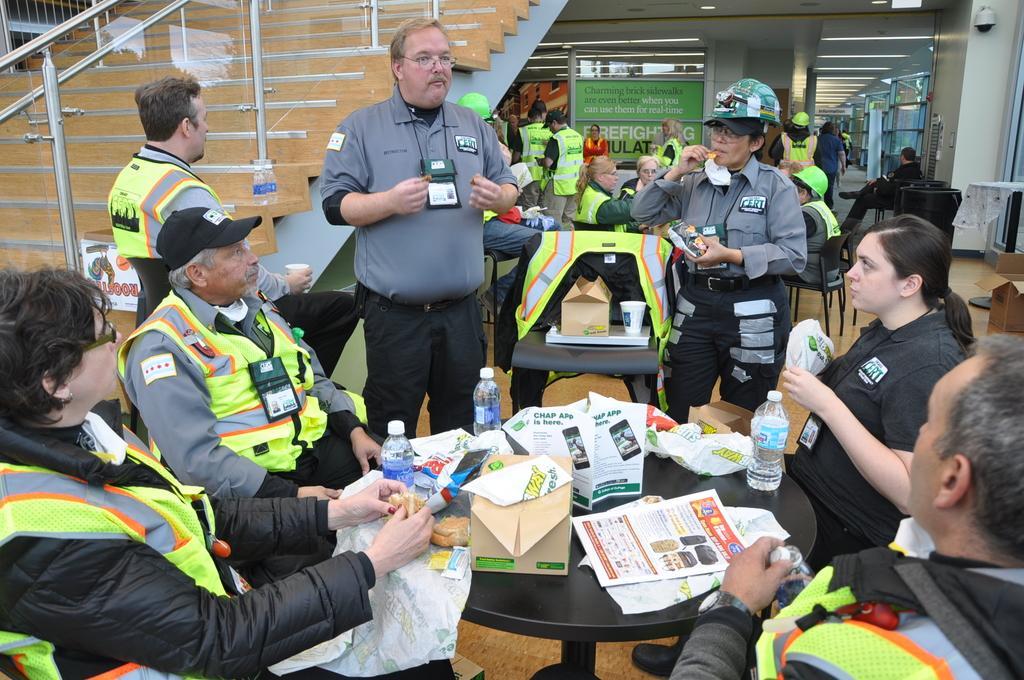Can you describe this image briefly? In this image there are four people sitting on chairs, in front of them on the table there are bottles of water and burgers, beside them there are two people standing, beside them there is a chair with a mug and a food parcel, beside the chair there is a woman standing, eating crisps, behind them there are a few other people standing and sitting in chairs, in the background of the image there are stairs with metal rod fencing on a glass and there is a camera on the wall. 